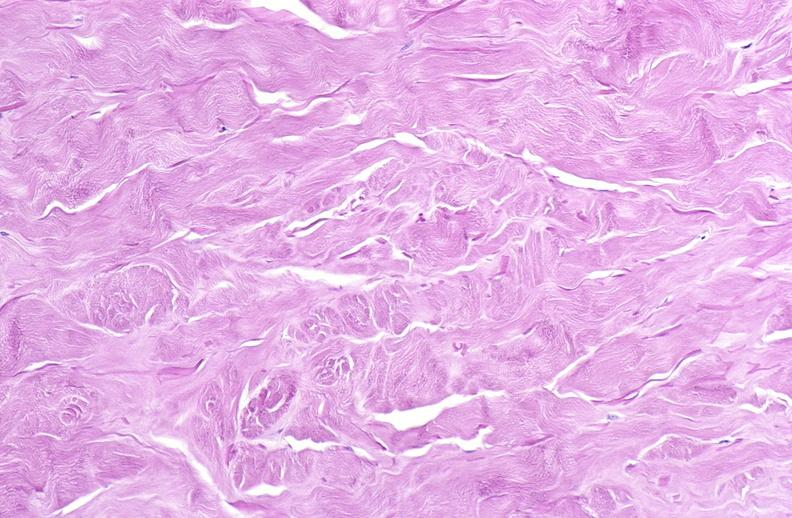does supernumerary digit show scleroderma?
Answer the question using a single word or phrase. No 